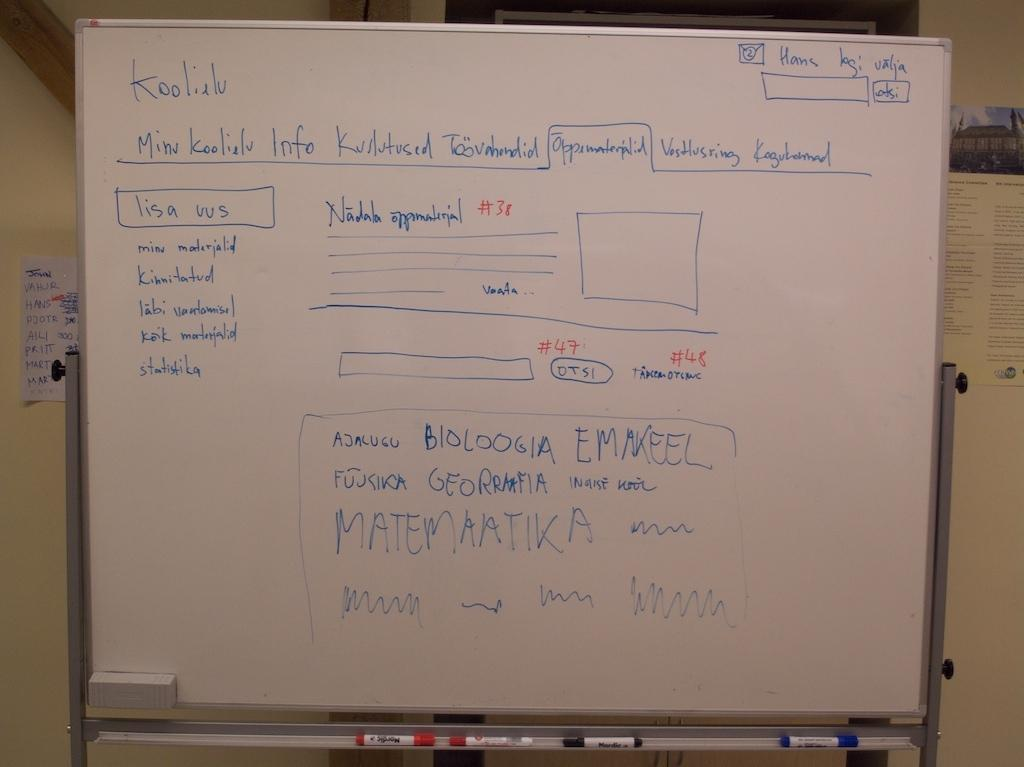<image>
Render a clear and concise summary of the photo. A whiteboard is used to sketch a website design for a page called Koolielu. 